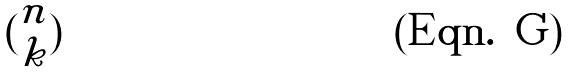<formula> <loc_0><loc_0><loc_500><loc_500>( \begin{matrix} n \\ k \end{matrix} )</formula> 